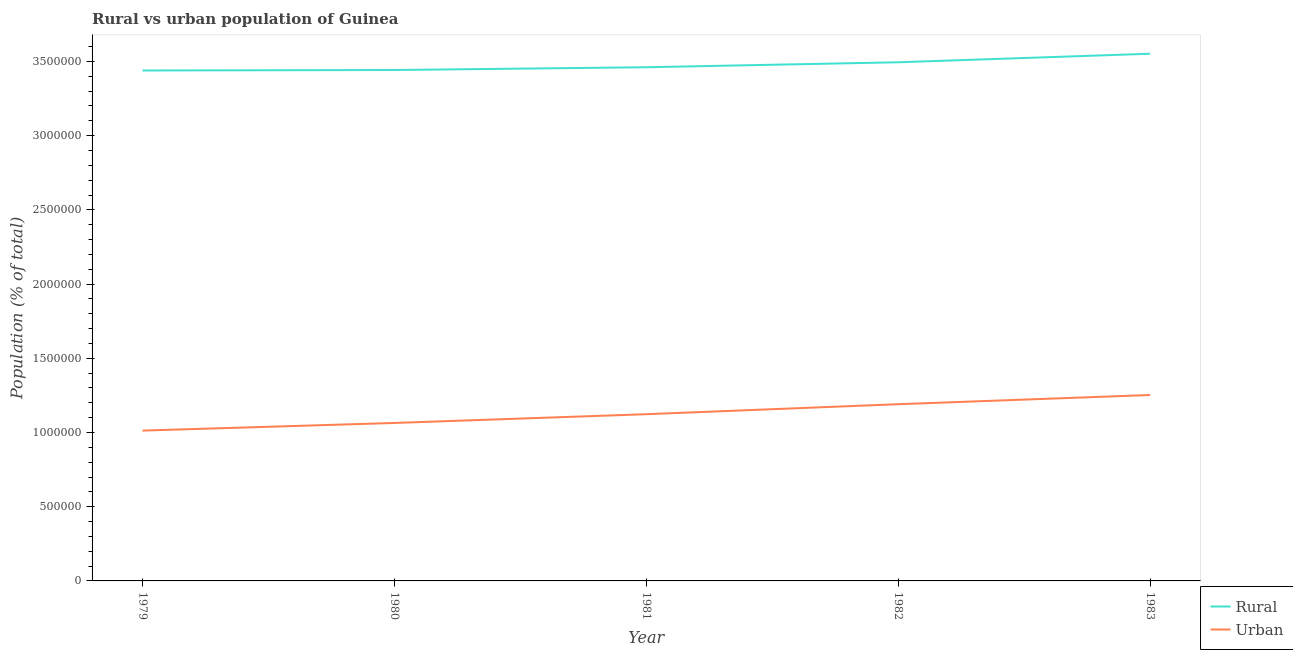Does the line corresponding to urban population density intersect with the line corresponding to rural population density?
Your response must be concise. No. Is the number of lines equal to the number of legend labels?
Ensure brevity in your answer.  Yes. What is the rural population density in 1981?
Give a very brief answer. 3.46e+06. Across all years, what is the maximum rural population density?
Your answer should be very brief. 3.55e+06. Across all years, what is the minimum rural population density?
Your response must be concise. 3.44e+06. In which year was the rural population density minimum?
Offer a very short reply. 1979. What is the total rural population density in the graph?
Offer a terse response. 1.74e+07. What is the difference between the urban population density in 1980 and that in 1982?
Offer a terse response. -1.26e+05. What is the difference between the urban population density in 1980 and the rural population density in 1982?
Provide a short and direct response. -2.43e+06. What is the average rural population density per year?
Your answer should be very brief. 3.48e+06. In the year 1979, what is the difference between the urban population density and rural population density?
Offer a very short reply. -2.43e+06. In how many years, is the urban population density greater than 2900000 %?
Give a very brief answer. 0. What is the ratio of the rural population density in 1979 to that in 1982?
Your answer should be very brief. 0.98. Is the urban population density in 1981 less than that in 1982?
Your answer should be compact. Yes. Is the difference between the urban population density in 1980 and 1983 greater than the difference between the rural population density in 1980 and 1983?
Offer a terse response. No. What is the difference between the highest and the second highest rural population density?
Ensure brevity in your answer.  5.77e+04. What is the difference between the highest and the lowest rural population density?
Ensure brevity in your answer.  1.13e+05. In how many years, is the rural population density greater than the average rural population density taken over all years?
Keep it short and to the point. 2. Is the sum of the urban population density in 1981 and 1983 greater than the maximum rural population density across all years?
Your answer should be very brief. No. Is the rural population density strictly less than the urban population density over the years?
Your answer should be compact. No. How many lines are there?
Offer a very short reply. 2. How many legend labels are there?
Give a very brief answer. 2. What is the title of the graph?
Give a very brief answer. Rural vs urban population of Guinea. What is the label or title of the X-axis?
Offer a very short reply. Year. What is the label or title of the Y-axis?
Ensure brevity in your answer.  Population (% of total). What is the Population (% of total) of Rural in 1979?
Provide a succinct answer. 3.44e+06. What is the Population (% of total) of Urban in 1979?
Keep it short and to the point. 1.01e+06. What is the Population (% of total) in Rural in 1980?
Your response must be concise. 3.44e+06. What is the Population (% of total) in Urban in 1980?
Your answer should be very brief. 1.06e+06. What is the Population (% of total) of Rural in 1981?
Your response must be concise. 3.46e+06. What is the Population (% of total) of Urban in 1981?
Your answer should be compact. 1.12e+06. What is the Population (% of total) in Rural in 1982?
Your response must be concise. 3.49e+06. What is the Population (% of total) of Urban in 1982?
Give a very brief answer. 1.19e+06. What is the Population (% of total) of Rural in 1983?
Keep it short and to the point. 3.55e+06. What is the Population (% of total) in Urban in 1983?
Give a very brief answer. 1.25e+06. Across all years, what is the maximum Population (% of total) in Rural?
Make the answer very short. 3.55e+06. Across all years, what is the maximum Population (% of total) of Urban?
Your answer should be compact. 1.25e+06. Across all years, what is the minimum Population (% of total) of Rural?
Offer a terse response. 3.44e+06. Across all years, what is the minimum Population (% of total) in Urban?
Provide a short and direct response. 1.01e+06. What is the total Population (% of total) of Rural in the graph?
Your response must be concise. 1.74e+07. What is the total Population (% of total) in Urban in the graph?
Keep it short and to the point. 5.64e+06. What is the difference between the Population (% of total) of Rural in 1979 and that in 1980?
Make the answer very short. -3174. What is the difference between the Population (% of total) in Urban in 1979 and that in 1980?
Your answer should be compact. -5.15e+04. What is the difference between the Population (% of total) of Rural in 1979 and that in 1981?
Provide a succinct answer. -2.19e+04. What is the difference between the Population (% of total) in Urban in 1979 and that in 1981?
Ensure brevity in your answer.  -1.10e+05. What is the difference between the Population (% of total) of Rural in 1979 and that in 1982?
Your response must be concise. -5.53e+04. What is the difference between the Population (% of total) of Urban in 1979 and that in 1982?
Give a very brief answer. -1.78e+05. What is the difference between the Population (% of total) in Rural in 1979 and that in 1983?
Provide a short and direct response. -1.13e+05. What is the difference between the Population (% of total) in Urban in 1979 and that in 1983?
Ensure brevity in your answer.  -2.40e+05. What is the difference between the Population (% of total) of Rural in 1980 and that in 1981?
Your answer should be very brief. -1.88e+04. What is the difference between the Population (% of total) of Urban in 1980 and that in 1981?
Provide a succinct answer. -5.90e+04. What is the difference between the Population (% of total) of Rural in 1980 and that in 1982?
Offer a terse response. -5.21e+04. What is the difference between the Population (% of total) of Urban in 1980 and that in 1982?
Offer a terse response. -1.26e+05. What is the difference between the Population (% of total) in Rural in 1980 and that in 1983?
Provide a succinct answer. -1.10e+05. What is the difference between the Population (% of total) of Urban in 1980 and that in 1983?
Provide a succinct answer. -1.88e+05. What is the difference between the Population (% of total) of Rural in 1981 and that in 1982?
Your answer should be compact. -3.33e+04. What is the difference between the Population (% of total) of Urban in 1981 and that in 1982?
Your answer should be very brief. -6.74e+04. What is the difference between the Population (% of total) in Rural in 1981 and that in 1983?
Give a very brief answer. -9.10e+04. What is the difference between the Population (% of total) in Urban in 1981 and that in 1983?
Provide a succinct answer. -1.29e+05. What is the difference between the Population (% of total) of Rural in 1982 and that in 1983?
Give a very brief answer. -5.77e+04. What is the difference between the Population (% of total) of Urban in 1982 and that in 1983?
Your answer should be compact. -6.20e+04. What is the difference between the Population (% of total) of Rural in 1979 and the Population (% of total) of Urban in 1980?
Provide a succinct answer. 2.37e+06. What is the difference between the Population (% of total) of Rural in 1979 and the Population (% of total) of Urban in 1981?
Offer a very short reply. 2.32e+06. What is the difference between the Population (% of total) in Rural in 1979 and the Population (% of total) in Urban in 1982?
Your answer should be very brief. 2.25e+06. What is the difference between the Population (% of total) in Rural in 1979 and the Population (% of total) in Urban in 1983?
Give a very brief answer. 2.19e+06. What is the difference between the Population (% of total) of Rural in 1980 and the Population (% of total) of Urban in 1981?
Offer a terse response. 2.32e+06. What is the difference between the Population (% of total) in Rural in 1980 and the Population (% of total) in Urban in 1982?
Your answer should be very brief. 2.25e+06. What is the difference between the Population (% of total) of Rural in 1980 and the Population (% of total) of Urban in 1983?
Your answer should be compact. 2.19e+06. What is the difference between the Population (% of total) in Rural in 1981 and the Population (% of total) in Urban in 1982?
Provide a succinct answer. 2.27e+06. What is the difference between the Population (% of total) in Rural in 1981 and the Population (% of total) in Urban in 1983?
Give a very brief answer. 2.21e+06. What is the difference between the Population (% of total) in Rural in 1982 and the Population (% of total) in Urban in 1983?
Keep it short and to the point. 2.24e+06. What is the average Population (% of total) in Rural per year?
Your response must be concise. 3.48e+06. What is the average Population (% of total) of Urban per year?
Offer a terse response. 1.13e+06. In the year 1979, what is the difference between the Population (% of total) of Rural and Population (% of total) of Urban?
Provide a succinct answer. 2.43e+06. In the year 1980, what is the difference between the Population (% of total) of Rural and Population (% of total) of Urban?
Your response must be concise. 2.38e+06. In the year 1981, what is the difference between the Population (% of total) in Rural and Population (% of total) in Urban?
Offer a terse response. 2.34e+06. In the year 1982, what is the difference between the Population (% of total) of Rural and Population (% of total) of Urban?
Provide a short and direct response. 2.30e+06. In the year 1983, what is the difference between the Population (% of total) in Rural and Population (% of total) in Urban?
Provide a succinct answer. 2.30e+06. What is the ratio of the Population (% of total) of Urban in 1979 to that in 1980?
Your response must be concise. 0.95. What is the ratio of the Population (% of total) in Urban in 1979 to that in 1981?
Your response must be concise. 0.9. What is the ratio of the Population (% of total) of Rural in 1979 to that in 1982?
Your answer should be very brief. 0.98. What is the ratio of the Population (% of total) in Urban in 1979 to that in 1982?
Offer a very short reply. 0.85. What is the ratio of the Population (% of total) of Rural in 1979 to that in 1983?
Ensure brevity in your answer.  0.97. What is the ratio of the Population (% of total) of Urban in 1979 to that in 1983?
Offer a terse response. 0.81. What is the ratio of the Population (% of total) in Rural in 1980 to that in 1981?
Make the answer very short. 0.99. What is the ratio of the Population (% of total) of Urban in 1980 to that in 1981?
Offer a terse response. 0.95. What is the ratio of the Population (% of total) of Rural in 1980 to that in 1982?
Provide a short and direct response. 0.99. What is the ratio of the Population (% of total) of Urban in 1980 to that in 1982?
Your answer should be compact. 0.89. What is the ratio of the Population (% of total) in Rural in 1980 to that in 1983?
Provide a succinct answer. 0.97. What is the ratio of the Population (% of total) of Urban in 1980 to that in 1983?
Your answer should be compact. 0.85. What is the ratio of the Population (% of total) in Rural in 1981 to that in 1982?
Keep it short and to the point. 0.99. What is the ratio of the Population (% of total) of Urban in 1981 to that in 1982?
Your response must be concise. 0.94. What is the ratio of the Population (% of total) in Rural in 1981 to that in 1983?
Keep it short and to the point. 0.97. What is the ratio of the Population (% of total) of Urban in 1981 to that in 1983?
Provide a succinct answer. 0.9. What is the ratio of the Population (% of total) of Rural in 1982 to that in 1983?
Your response must be concise. 0.98. What is the ratio of the Population (% of total) of Urban in 1982 to that in 1983?
Make the answer very short. 0.95. What is the difference between the highest and the second highest Population (% of total) of Rural?
Your response must be concise. 5.77e+04. What is the difference between the highest and the second highest Population (% of total) in Urban?
Give a very brief answer. 6.20e+04. What is the difference between the highest and the lowest Population (% of total) in Rural?
Give a very brief answer. 1.13e+05. What is the difference between the highest and the lowest Population (% of total) of Urban?
Offer a very short reply. 2.40e+05. 